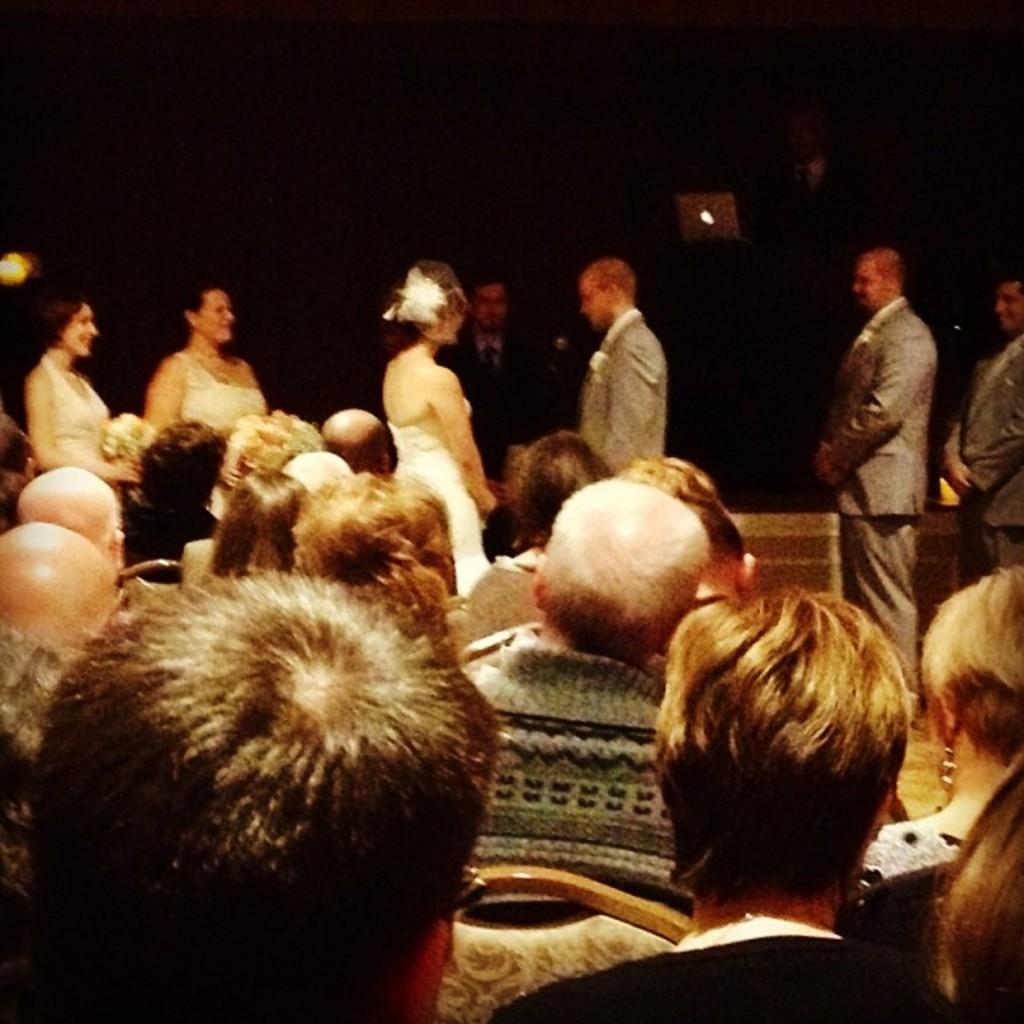In one or two sentences, can you explain what this image depicts? In this image I can see a group of people sitting and few people are standing. They are wearing different color dresses. Background is black in color. 